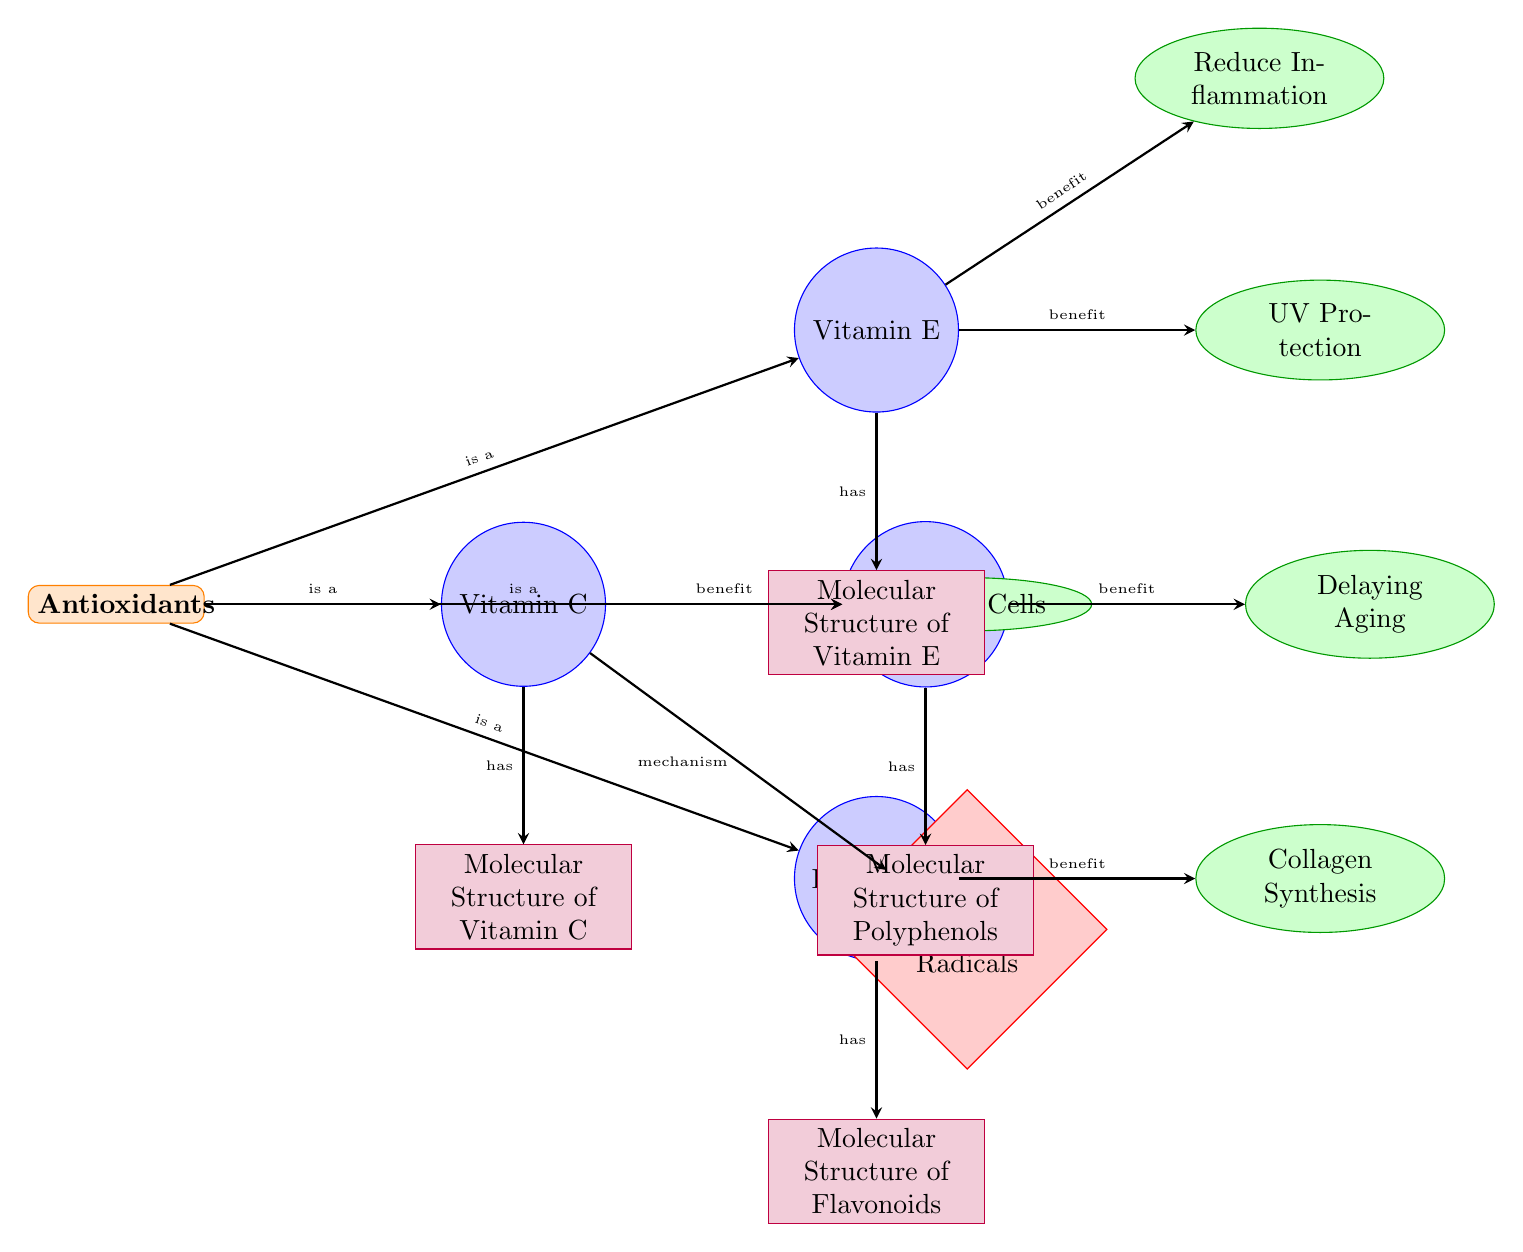What are the four types of antioxidants listed in the diagram? The diagram shows a category labeled "Antioxidants," which is directly connected to four nodes: Vitamin C, Vitamin E, Flavonoids, and Polyphenols.
Answer: Vitamin C, Vitamin E, Flavonoids, Polyphenols How many benefits are listed in the diagram? There are five nodes labeled as benefits connected to the antioxidant nodes. These are Protect Cells, Reduce Inflammation, UV Protection, Collagen Synthesis, and Delaying Aging, indicating a total of five benefits.
Answer: 5 What mechanism is described for Vitamin C? The mechanism node connected to Vitamin C is labeled as "Scavenging Free Radicals," indicating how Vitamin C works on a cellular level.
Answer: Scavenging Free Radicals Which antioxidant is associated with reducing inflammation? The diagram shows that Vitamin E is connected to the benefit labeled "Reduce Inflammation," indicating that this antioxidant has this specific effect.
Answer: Vitamin E What is the relationship between Flavonoids and Collagen Synthesis? Flavonoids are directly connected to the benefit node "Collagen Synthesis" in the diagram, indicating that Flavonoids have a role in promoting this process.
Answer: Benefit Describe the relationship between antioxidants and their molecular structures. Each antioxidant node has a connecting edge labeled "has" that leads to its corresponding molecular structure node, showing that every antioxidant is associated with a specific molecular structure.
Answer: Has What benefit is Vitamin C specifically linked to in this diagram? Vitamin C is connected to the benefit node labeled "Protect Cells," demonstrating its specific advantage in skincare.
Answer: Protect Cells Why is the concept of scavenging free radicals important in this diagram? This mechanism, labeled "Scavenging Free Radicals," is crucial because it connects directly to Vitamin C and describes the underlying action that helps the associated benefits, like cell protection.
Answer: Important 